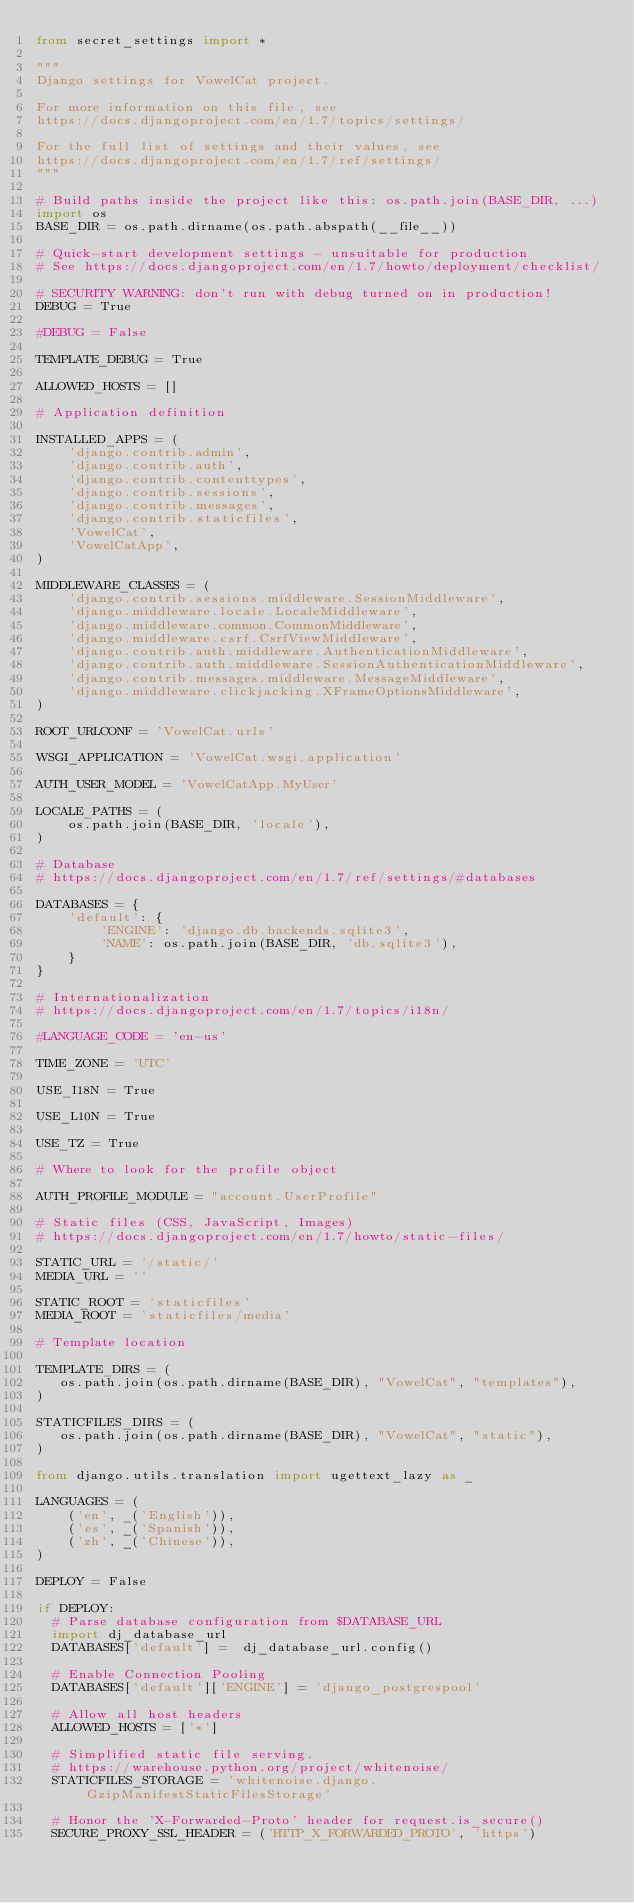<code> <loc_0><loc_0><loc_500><loc_500><_Python_>from secret_settings import *

"""
Django settings for VowelCat project.

For more information on this file, see
https://docs.djangoproject.com/en/1.7/topics/settings/

For the full list of settings and their values, see
https://docs.djangoproject.com/en/1.7/ref/settings/
"""

# Build paths inside the project like this: os.path.join(BASE_DIR, ...)
import os
BASE_DIR = os.path.dirname(os.path.abspath(__file__))

# Quick-start development settings - unsuitable for production
# See https://docs.djangoproject.com/en/1.7/howto/deployment/checklist/

# SECURITY WARNING: don't run with debug turned on in production!
DEBUG = True

#DEBUG = False

TEMPLATE_DEBUG = True

ALLOWED_HOSTS = []

# Application definition

INSTALLED_APPS = (
    'django.contrib.admin',
    'django.contrib.auth',
    'django.contrib.contenttypes',
    'django.contrib.sessions',
    'django.contrib.messages',
    'django.contrib.staticfiles',
    'VowelCat',
    'VowelCatApp',
)

MIDDLEWARE_CLASSES = (
    'django.contrib.sessions.middleware.SessionMiddleware',      
    'django.middleware.locale.LocaleMiddleware',    
    'django.middleware.common.CommonMiddleware', 
    'django.middleware.csrf.CsrfViewMiddleware',
    'django.contrib.auth.middleware.AuthenticationMiddleware',
    'django.contrib.auth.middleware.SessionAuthenticationMiddleware',
    'django.contrib.messages.middleware.MessageMiddleware',
    'django.middleware.clickjacking.XFrameOptionsMiddleware',
)

ROOT_URLCONF = 'VowelCat.urls'

WSGI_APPLICATION = 'VowelCat.wsgi.application'

AUTH_USER_MODEL = 'VowelCatApp.MyUser'

LOCALE_PATHS = (
    os.path.join(BASE_DIR, 'locale'),
)

# Database
# https://docs.djangoproject.com/en/1.7/ref/settings/#databases

DATABASES = {
    'default': {
        'ENGINE': 'django.db.backends.sqlite3',
        'NAME': os.path.join(BASE_DIR, 'db.sqlite3'),
    }
}

# Internationalization
# https://docs.djangoproject.com/en/1.7/topics/i18n/

#LANGUAGE_CODE = 'en-us'

TIME_ZONE = 'UTC'

USE_I18N = True

USE_L10N = True

USE_TZ = True

# Where to look for the profile object

AUTH_PROFILE_MODULE = "account.UserProfile"

# Static files (CSS, JavaScript, Images)
# https://docs.djangoproject.com/en/1.7/howto/static-files/

STATIC_URL = '/static/'
MEDIA_URL = ''

STATIC_ROOT = 'staticfiles'
MEDIA_ROOT = 'staticfiles/media'

# Template location

TEMPLATE_DIRS = (
   os.path.join(os.path.dirname(BASE_DIR), "VowelCat", "templates"),
)

STATICFILES_DIRS = (
   os.path.join(os.path.dirname(BASE_DIR), "VowelCat", "static"),
)

from django.utils.translation import ugettext_lazy as _

LANGUAGES = (
    ('en', _('English')),
    ('es', _('Spanish')),
    ('zh', _('Chinese')),
)

DEPLOY = False

if DEPLOY:
  # Parse database configuration from $DATABASE_URL
  import dj_database_url
  DATABASES['default'] =  dj_database_url.config()

  # Enable Connection Pooling
  DATABASES['default']['ENGINE'] = 'django_postgrespool'

  # Allow all host headers
  ALLOWED_HOSTS = ['*']

  # Simplified static file serving.
  # https://warehouse.python.org/project/whitenoise/
  STATICFILES_STORAGE = 'whitenoise.django.GzipManifestStaticFilesStorage'

  # Honor the 'X-Forwarded-Proto' header for request.is_secure()
  SECURE_PROXY_SSL_HEADER = ('HTTP_X_FORWARDED_PROTO', 'https')
</code> 